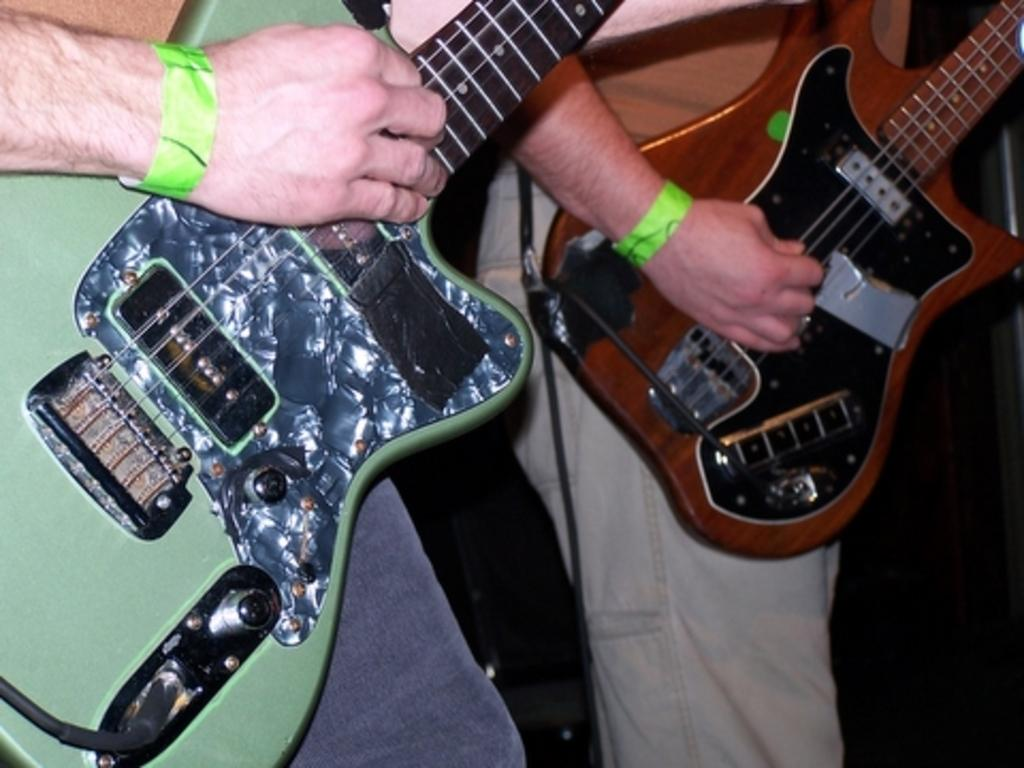How many people are in the image? There are two persons in the image. What are the persons doing in the image? Both persons are playing guitars. Can you describe the guitars in the image? There is a green guitar on the left side and a brown guitar on the right side. What are the persons wearing on their wrists? The persons are wearing green wristbands. Where is the table located in the image? There is no table present in the image. Can you describe the plastic material used in the image? There is no plastic material mentioned or visible in the image. 